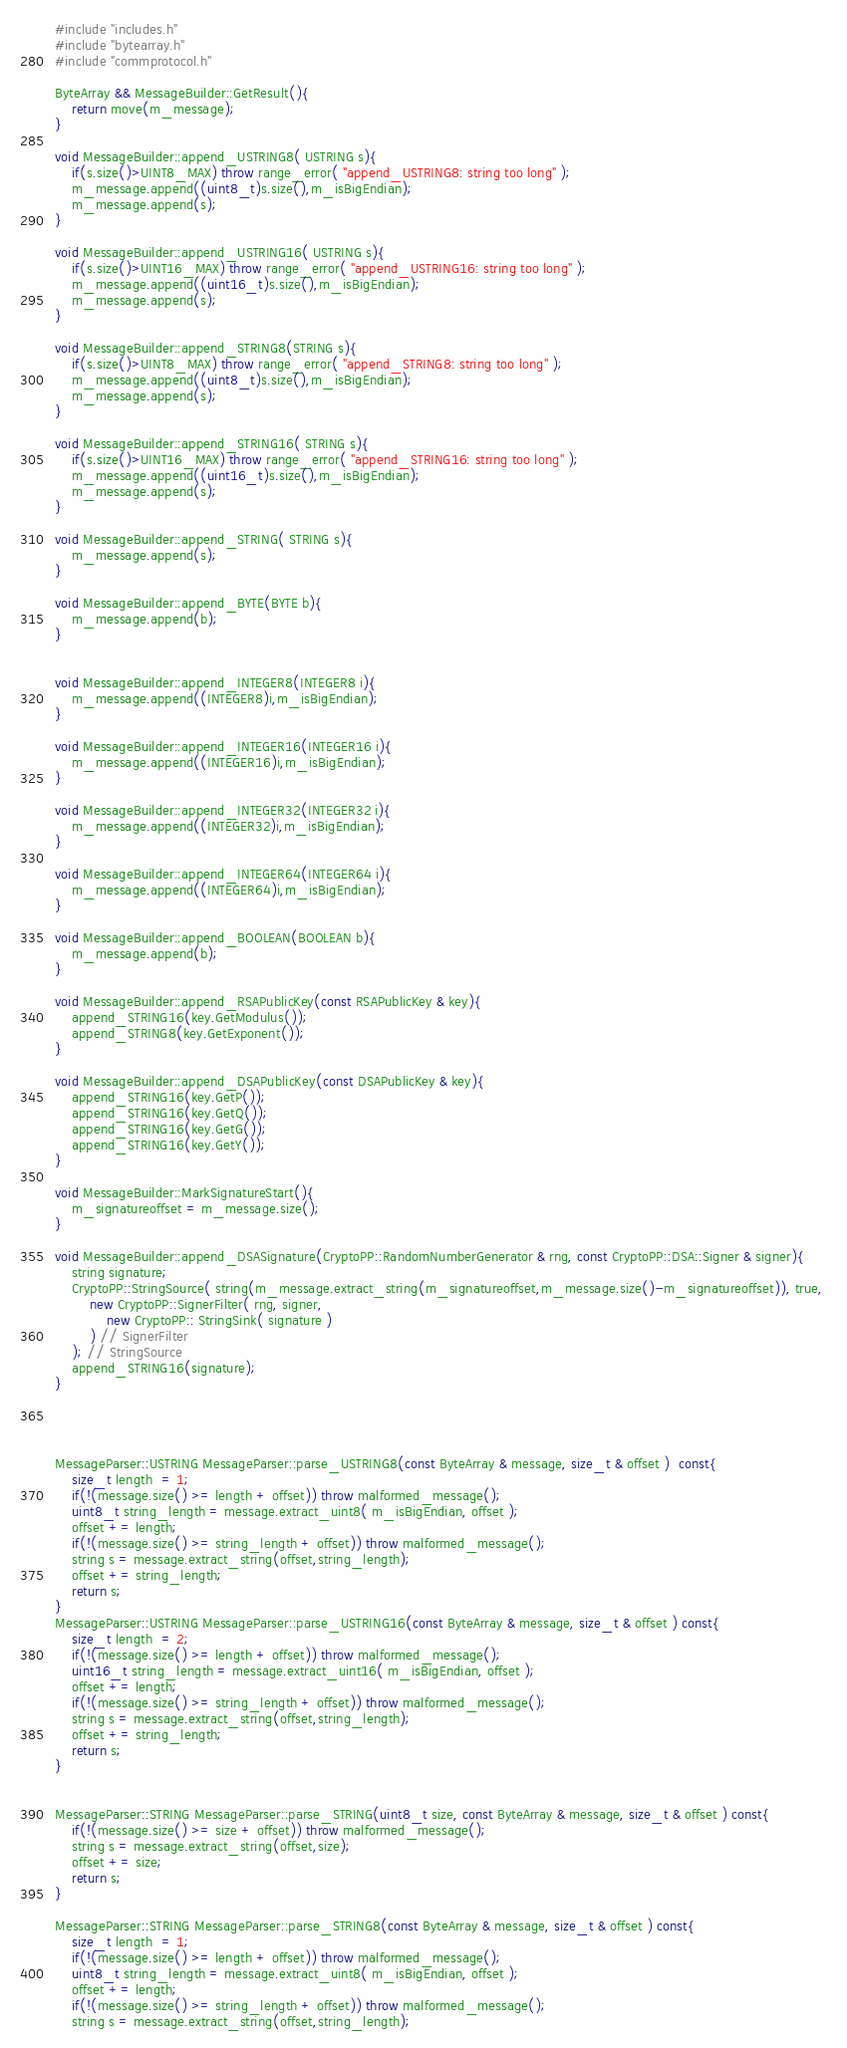<code> <loc_0><loc_0><loc_500><loc_500><_C++_>#include "includes.h"
#include "bytearray.h"
#include "commprotocol.h"

ByteArray && MessageBuilder::GetResult(){
	return move(m_message);
}

void MessageBuilder::append_USTRING8( USTRING s){
	if(s.size()>UINT8_MAX) throw range_error( "append_USTRING8: string too long" );
	m_message.append((uint8_t)s.size(),m_isBigEndian);
	m_message.append(s);
}

void MessageBuilder::append_USTRING16( USTRING s){
	if(s.size()>UINT16_MAX) throw range_error( "append_USTRING16: string too long" );
	m_message.append((uint16_t)s.size(),m_isBigEndian);
	m_message.append(s);
}

void MessageBuilder::append_STRING8(STRING s){
	if(s.size()>UINT8_MAX) throw range_error( "append_STRING8: string too long" );
	m_message.append((uint8_t)s.size(),m_isBigEndian);
	m_message.append(s);
}

void MessageBuilder::append_STRING16( STRING s){
	if(s.size()>UINT16_MAX) throw range_error( "append_STRING16: string too long" );
	m_message.append((uint16_t)s.size(),m_isBigEndian);
	m_message.append(s); 
}

void MessageBuilder::append_STRING( STRING s){
	m_message.append(s);
}

void MessageBuilder::append_BYTE(BYTE b){
	m_message.append(b);
}


void MessageBuilder::append_INTEGER8(INTEGER8 i){
	m_message.append((INTEGER8)i,m_isBigEndian);
}

void MessageBuilder::append_INTEGER16(INTEGER16 i){
	m_message.append((INTEGER16)i,m_isBigEndian);
}

void MessageBuilder::append_INTEGER32(INTEGER32 i){
	m_message.append((INTEGER32)i,m_isBigEndian);
}

void MessageBuilder::append_INTEGER64(INTEGER64 i){
	m_message.append((INTEGER64)i,m_isBigEndian);
}

void MessageBuilder::append_BOOLEAN(BOOLEAN b){
	m_message.append(b);
}

void MessageBuilder::append_RSAPublicKey(const RSAPublicKey & key){
	append_STRING16(key.GetModulus());
	append_STRING8(key.GetExponent());
}

void MessageBuilder::append_DSAPublicKey(const DSAPublicKey & key){
	append_STRING16(key.GetP());
	append_STRING16(key.GetQ());
	append_STRING16(key.GetG());
	append_STRING16(key.GetY());
}

void MessageBuilder::MarkSignatureStart(){
	m_signatureoffset = m_message.size();
}

void MessageBuilder::append_DSASignature(CryptoPP::RandomNumberGenerator & rng, const CryptoPP::DSA::Signer & signer){
	string signature;
	CryptoPP::StringSource( string(m_message.extract_string(m_signatureoffset,m_message.size()-m_signatureoffset)), true, 
		new CryptoPP::SignerFilter( rng, signer,
			new CryptoPP:: StringSink( signature )
		) // SignerFilter
	); // StringSource
	append_STRING16(signature);
}




MessageParser::USTRING MessageParser::parse_USTRING8(const ByteArray & message, size_t & offset )  const{
	size_t length  = 1;
	if(!(message.size() >= length + offset)) throw malformed_message();
	uint8_t string_length = message.extract_uint8( m_isBigEndian, offset );
	offset += length;
	if(!(message.size() >= string_length + offset)) throw malformed_message();
	string s = message.extract_string(offset,string_length);
	offset += string_length;
	return s;
}
MessageParser::USTRING MessageParser::parse_USTRING16(const ByteArray & message, size_t & offset ) const{
	size_t length  = 2;
	if(!(message.size() >= length + offset)) throw malformed_message();
	uint16_t string_length = message.extract_uint16( m_isBigEndian, offset );
	offset += length;
	if(!(message.size() >= string_length + offset)) throw malformed_message();
	string s = message.extract_string(offset,string_length);
	offset += string_length;
	return s;
}


MessageParser::STRING MessageParser::parse_STRING(uint8_t size, const ByteArray & message, size_t & offset ) const{
	if(!(message.size() >= size + offset)) throw malformed_message();
	string s = message.extract_string(offset,size);
	offset += size;
	return s;
}

MessageParser::STRING MessageParser::parse_STRING8(const ByteArray & message, size_t & offset ) const{
	size_t length  = 1;
	if(!(message.size() >= length + offset)) throw malformed_message();
	uint8_t string_length = message.extract_uint8( m_isBigEndian, offset );
	offset += length;
	if(!(message.size() >= string_length + offset)) throw malformed_message();
	string s = message.extract_string(offset,string_length);</code> 